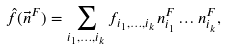<formula> <loc_0><loc_0><loc_500><loc_500>\hat { f } ( \vec { n } ^ { F } ) = \sum _ { i _ { 1 } , \dots , i _ { k } } f _ { i _ { 1 } , \dots , i _ { k } } n _ { i _ { 1 } } ^ { F } \dots n _ { i _ { k } } ^ { F } ,</formula> 